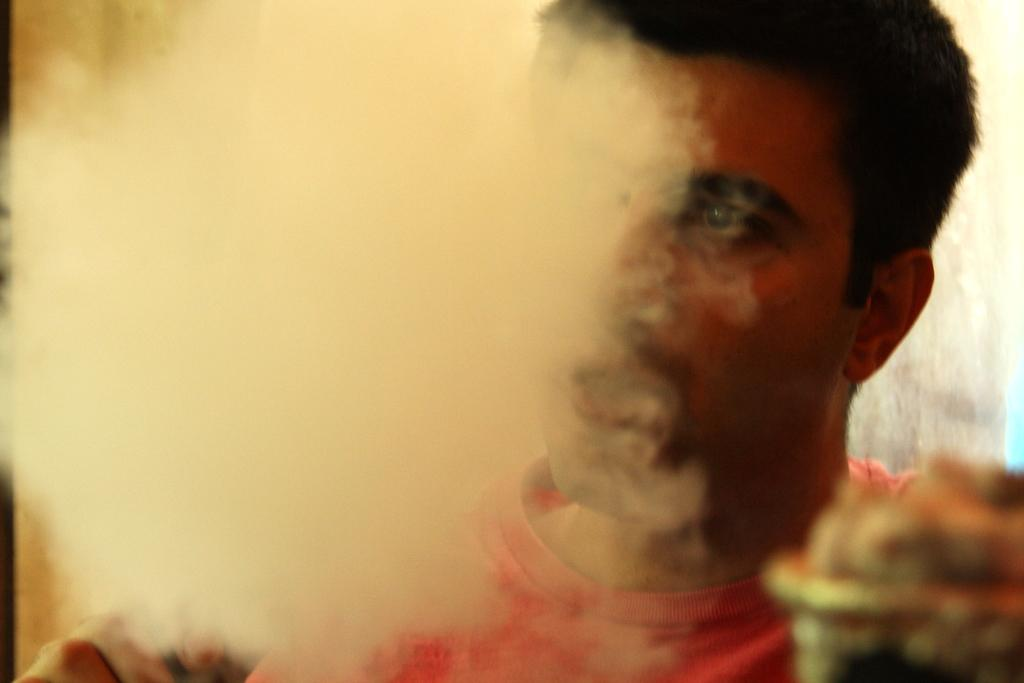What is the main subject of the image? The main subject of the image is a man. What can be observed about the man's attire? The man is wearing clothes. What additional detail can be seen in the image? There is smoke visible in the image. What type of pleasure is the man experiencing in the image? There is no indication of pleasure or any specific emotion in the image, as it is a close-up of a man with smoke visible. What mode of transport is the man using in the image? There is no mode of transport present in the image; it is a close-up of a man with smoke visible. 